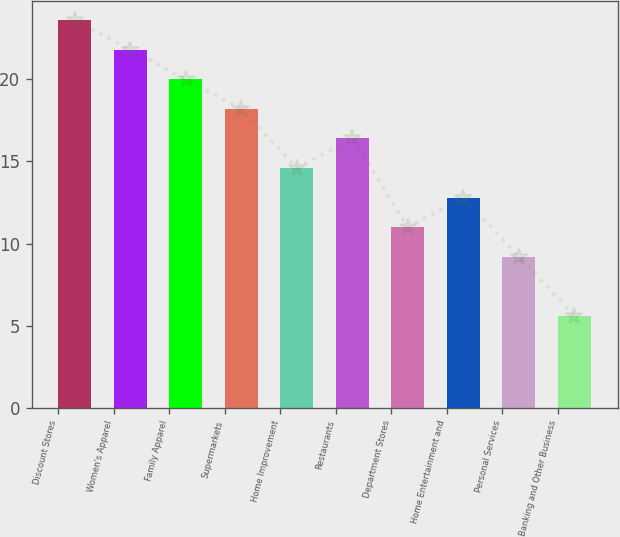<chart> <loc_0><loc_0><loc_500><loc_500><bar_chart><fcel>Discount Stores<fcel>Women's Apparel<fcel>Family Apparel<fcel>Supermarkets<fcel>Home Improvement<fcel>Restaurants<fcel>Department Stores<fcel>Home Entertainment and<fcel>Personal Services<fcel>Banking and Other Business<nl><fcel>23.6<fcel>21.8<fcel>20<fcel>18.2<fcel>14.6<fcel>16.4<fcel>11<fcel>12.8<fcel>9.2<fcel>5.6<nl></chart> 